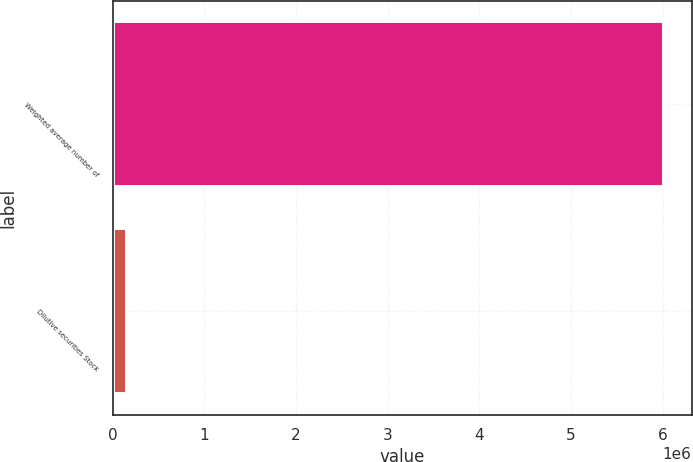Convert chart to OTSL. <chart><loc_0><loc_0><loc_500><loc_500><bar_chart><fcel>Weighted average number of<fcel>Dilutive securities Stock<nl><fcel>6.01607e+06<fcel>154658<nl></chart> 